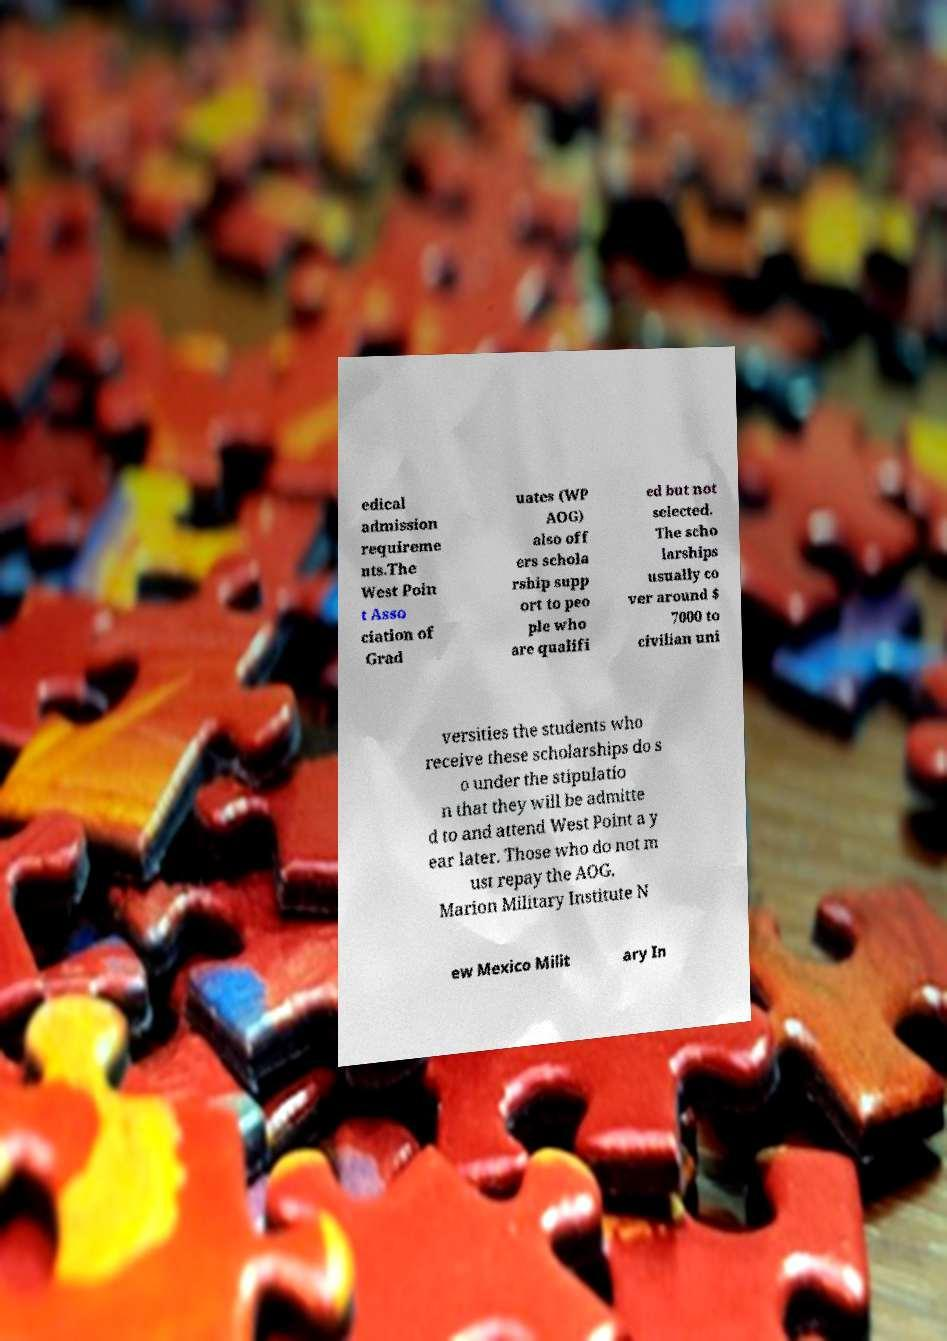I need the written content from this picture converted into text. Can you do that? edical admission requireme nts.The West Poin t Asso ciation of Grad uates (WP AOG) also off ers schola rship supp ort to peo ple who are qualifi ed but not selected. The scho larships usually co ver around $ 7000 to civilian uni versities the students who receive these scholarships do s o under the stipulatio n that they will be admitte d to and attend West Point a y ear later. Those who do not m ust repay the AOG. Marion Military Institute N ew Mexico Milit ary In 